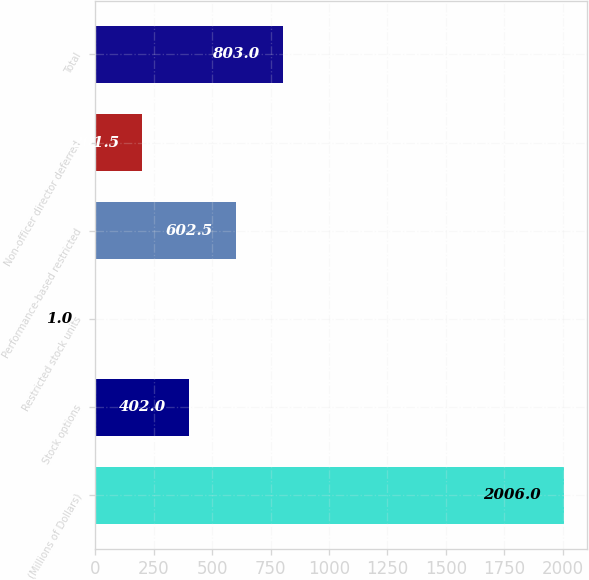Convert chart to OTSL. <chart><loc_0><loc_0><loc_500><loc_500><bar_chart><fcel>(Millions of Dollars)<fcel>Stock options<fcel>Restricted stock units<fcel>Performance-based restricted<fcel>Non-officer director deferred<fcel>Total<nl><fcel>2006<fcel>402<fcel>1<fcel>602.5<fcel>201.5<fcel>803<nl></chart> 